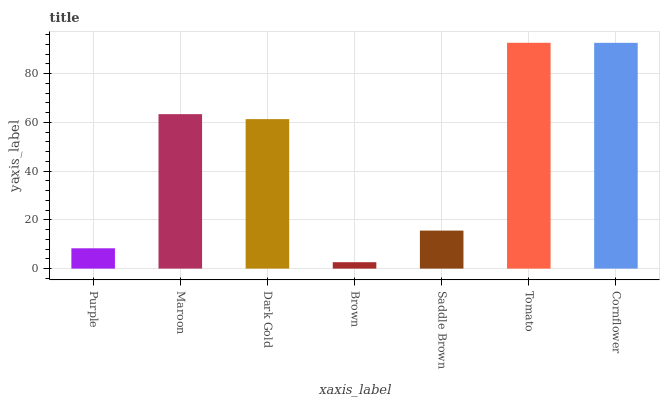Is Brown the minimum?
Answer yes or no. Yes. Is Tomato the maximum?
Answer yes or no. Yes. Is Maroon the minimum?
Answer yes or no. No. Is Maroon the maximum?
Answer yes or no. No. Is Maroon greater than Purple?
Answer yes or no. Yes. Is Purple less than Maroon?
Answer yes or no. Yes. Is Purple greater than Maroon?
Answer yes or no. No. Is Maroon less than Purple?
Answer yes or no. No. Is Dark Gold the high median?
Answer yes or no. Yes. Is Dark Gold the low median?
Answer yes or no. Yes. Is Purple the high median?
Answer yes or no. No. Is Tomato the low median?
Answer yes or no. No. 